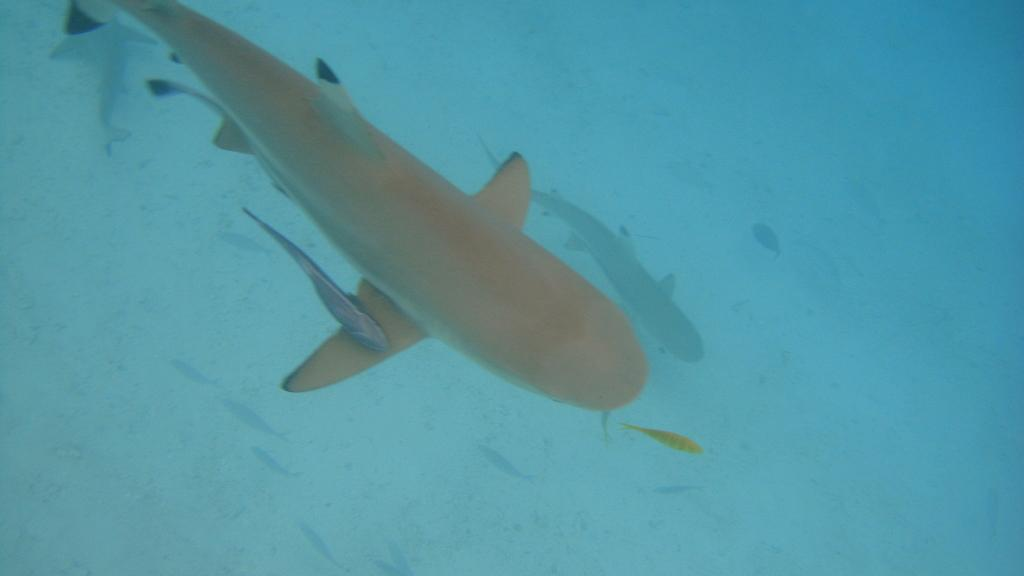What type of animals can be seen in the image? There are fishes in the image. Where are the fishes located? The fishes are in the water. What type of home can be seen in the image? There is no home present in the image; it features fishes in the water. What is the fishes' reaction to the person saying good-bye in the image? There is no person saying good-bye in the image, and the fishes cannot react to such an event as they are not sentient beings. 